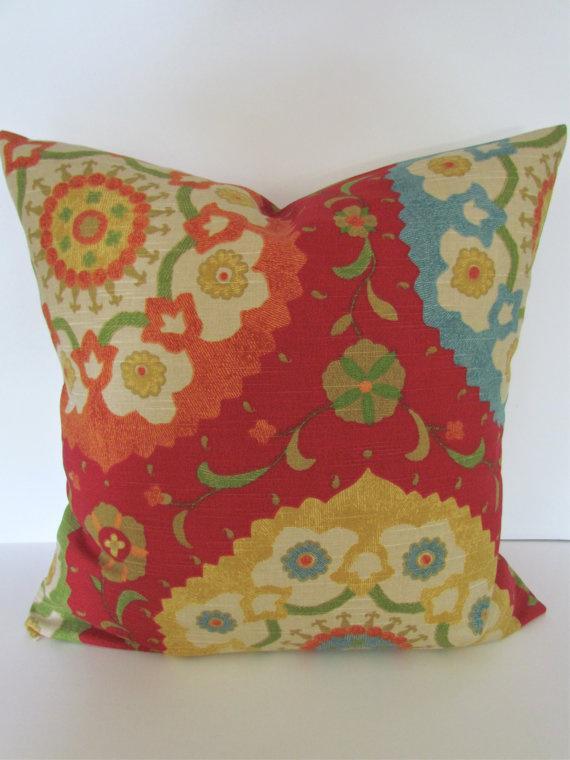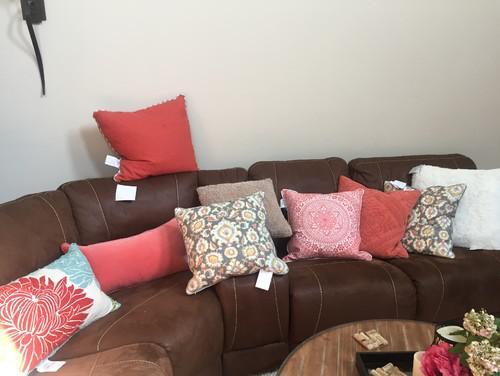The first image is the image on the left, the second image is the image on the right. Considering the images on both sides, is "The pillow display in one image includes a round wheel shape with a button center." valid? Answer yes or no. No. The first image is the image on the left, the second image is the image on the right. Given the left and right images, does the statement "Some of the pillows are round in shape." hold true? Answer yes or no. No. 